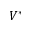<formula> <loc_0><loc_0><loc_500><loc_500>V ^ { * }</formula> 